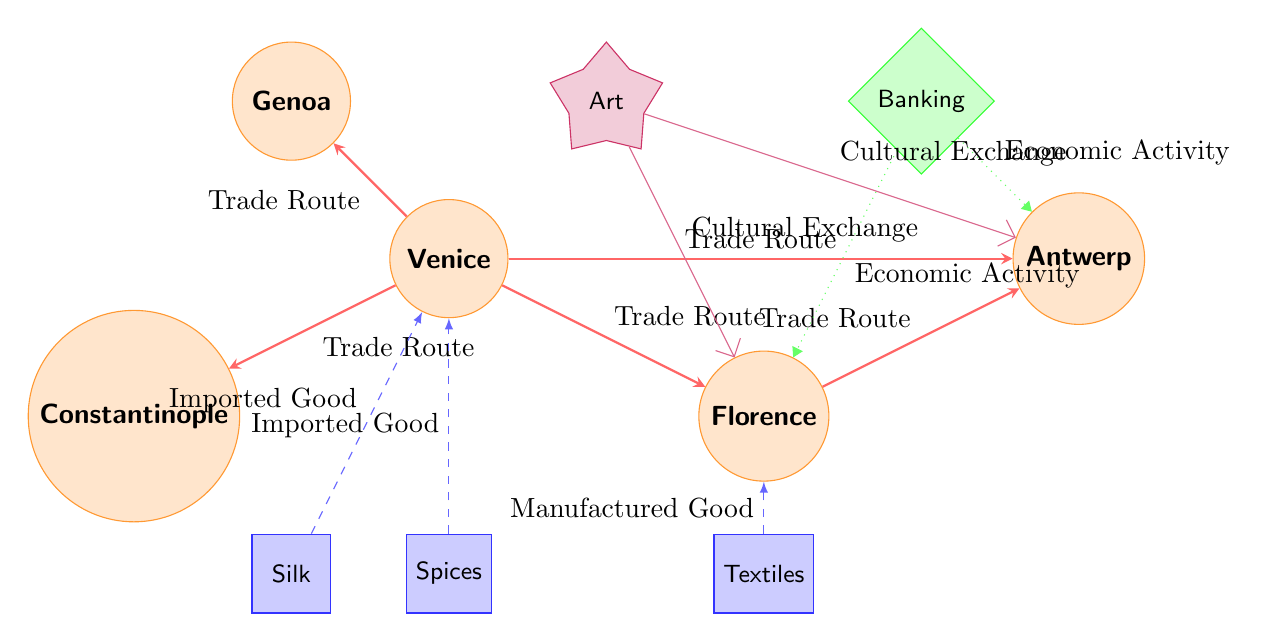What are the imported goods in Venice? The diagram indicates that Venice imports Silk and Spices. These are connected to Venice with an "Imported Good" label.
Answer: Silk, Spices How many trade routes originate from Venice? The diagram shows that there are five arrows labeled "Trade Route" originating from Venice leading to other cities.
Answer: Five Which city has a direct trade route to both Florence and Antwerp? The diagram illustrates a direct trade route from Florence to Antwerp. Therefore, Florence is the city that connects to both cities via a trade route.
Answer: Florence What is the economic activity linked with banking? The diagram reveals that both Florence and Antwerp are associated with economic activity through the Banking node. Thus, these cities are related to banking's economic activities.
Answer: Florence, Antwerp What types of goods does Florence manufacture? According to the diagram, the only manufactured good attributed to Florence is Textiles, denoted by the "Manufactured Good" label leading to Florence.
Answer: Textiles Which city is the cultural exchange hub for the Art node? The diagram shows that Art has cultural exchange links to both Florence and Antwerp, indicating both cities are considered hubs of cultural exchange related to Art.
Answer: Florence, Antwerp What are the major economic centers depicted in the diagram? The diagram includes one economic center, which is Banking. This is represented as a diamond-shaped node in green, indicating its significance in the economic network.
Answer: Banking Which city exports goods to Constantinople? The trade routes direction illustrates that Venice exports goods (Silk and Spices) to Constantinople, making Venice the exporter.
Answer: Venice How many cities are depicted in the diagram? By counting the circular nodes labeled as cities in the diagram, we find there are five cities represented: Venice, Florence, Antwerp, Constantinople, and Genoa.
Answer: Five 